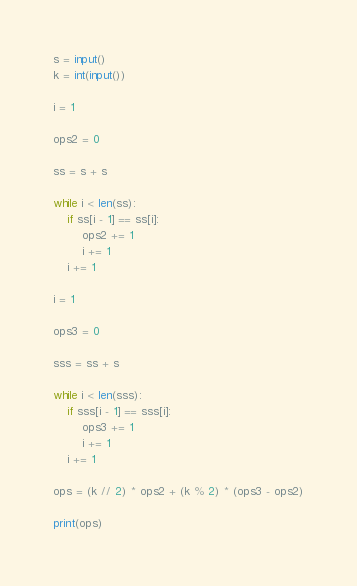Convert code to text. <code><loc_0><loc_0><loc_500><loc_500><_Python_>s = input()
k = int(input())

i = 1

ops2 = 0

ss = s + s

while i < len(ss):
    if ss[i - 1] == ss[i]:
        ops2 += 1
        i += 1
    i += 1

i = 1

ops3 = 0

sss = ss + s

while i < len(sss):
    if sss[i - 1] == sss[i]:
        ops3 += 1
        i += 1
    i += 1

ops = (k // 2) * ops2 + (k % 2) * (ops3 - ops2)

print(ops)</code> 